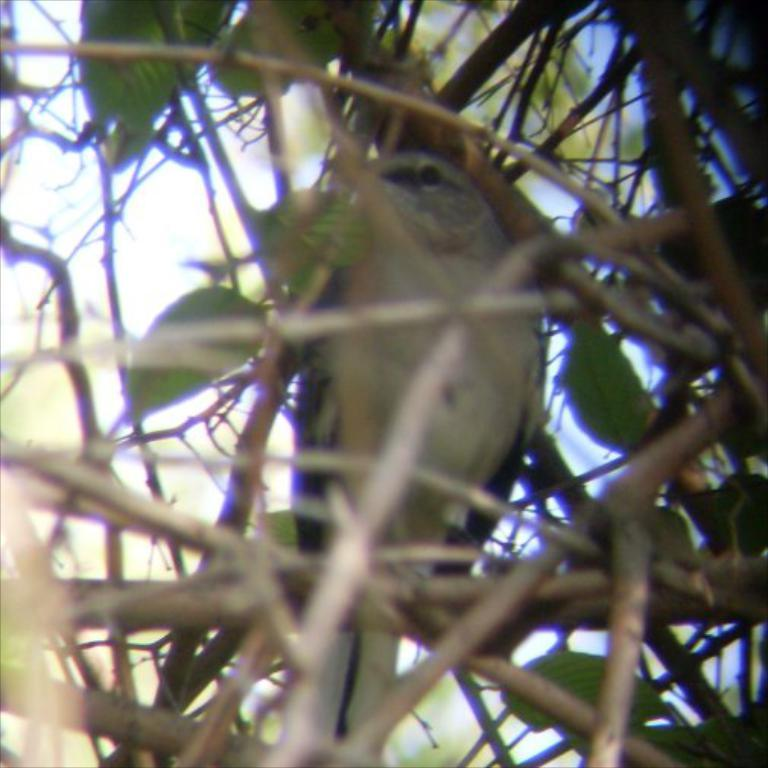What type of plant life is visible in the image? There are stems and leaves in the image. Is there any wildlife present in the image? Yes, there is a bird sitting on a stem in the image. What can be seen in the background of the image? The sky is visible in the background of the image. How many holes can be seen in the bird's beak in the image? There are no holes visible in the bird's beak in the image. 